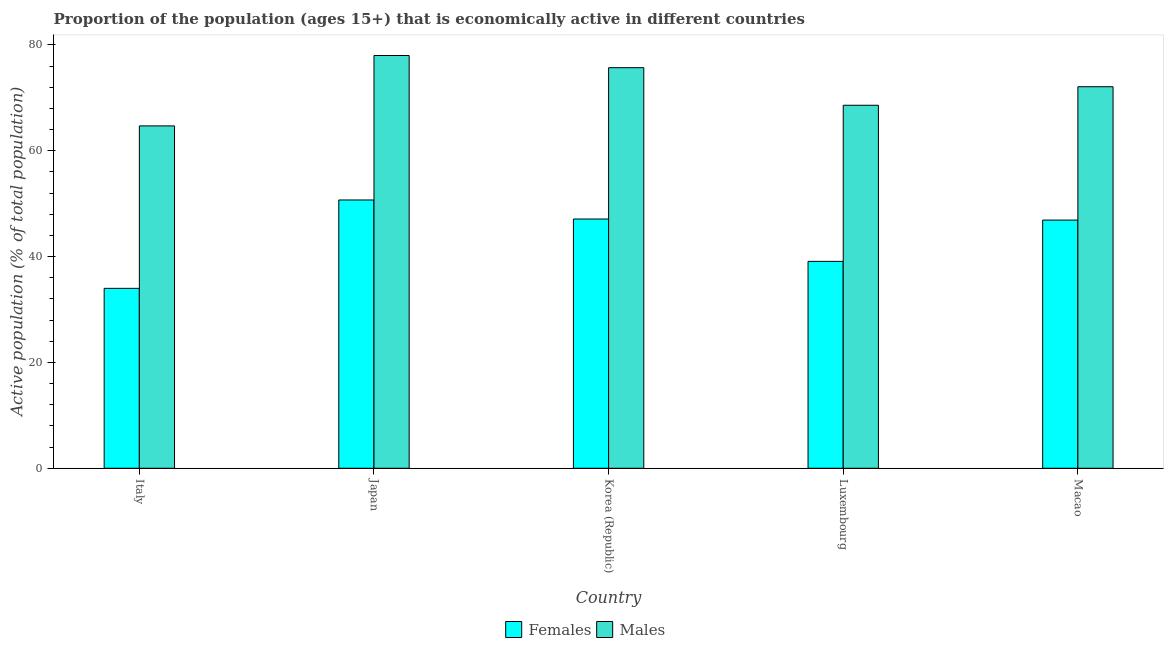How many groups of bars are there?
Offer a very short reply. 5. Are the number of bars per tick equal to the number of legend labels?
Provide a short and direct response. Yes. Are the number of bars on each tick of the X-axis equal?
Give a very brief answer. Yes. How many bars are there on the 1st tick from the left?
Keep it short and to the point. 2. How many bars are there on the 3rd tick from the right?
Provide a succinct answer. 2. What is the percentage of economically active male population in Korea (Republic)?
Provide a short and direct response. 75.7. Across all countries, what is the maximum percentage of economically active female population?
Your response must be concise. 50.7. Across all countries, what is the minimum percentage of economically active female population?
Offer a terse response. 34. In which country was the percentage of economically active female population minimum?
Provide a short and direct response. Italy. What is the total percentage of economically active female population in the graph?
Provide a succinct answer. 217.8. What is the difference between the percentage of economically active male population in Italy and that in Macao?
Provide a succinct answer. -7.4. What is the difference between the percentage of economically active female population in Japan and the percentage of economically active male population in Korea (Republic)?
Your response must be concise. -25. What is the average percentage of economically active male population per country?
Give a very brief answer. 71.82. What is the difference between the percentage of economically active male population and percentage of economically active female population in Macao?
Your answer should be compact. 25.2. What is the ratio of the percentage of economically active male population in Korea (Republic) to that in Macao?
Give a very brief answer. 1.05. Is the percentage of economically active male population in Japan less than that in Macao?
Keep it short and to the point. No. Is the difference between the percentage of economically active male population in Japan and Macao greater than the difference between the percentage of economically active female population in Japan and Macao?
Your answer should be very brief. Yes. What is the difference between the highest and the second highest percentage of economically active male population?
Your response must be concise. 2.3. What is the difference between the highest and the lowest percentage of economically active female population?
Your answer should be very brief. 16.7. What does the 1st bar from the left in Macao represents?
Make the answer very short. Females. What does the 2nd bar from the right in Italy represents?
Make the answer very short. Females. Are all the bars in the graph horizontal?
Keep it short and to the point. No. How many countries are there in the graph?
Offer a very short reply. 5. Are the values on the major ticks of Y-axis written in scientific E-notation?
Provide a short and direct response. No. Does the graph contain any zero values?
Provide a succinct answer. No. Does the graph contain grids?
Your response must be concise. No. Where does the legend appear in the graph?
Your response must be concise. Bottom center. How many legend labels are there?
Your answer should be compact. 2. How are the legend labels stacked?
Offer a very short reply. Horizontal. What is the title of the graph?
Give a very brief answer. Proportion of the population (ages 15+) that is economically active in different countries. What is the label or title of the X-axis?
Make the answer very short. Country. What is the label or title of the Y-axis?
Offer a very short reply. Active population (% of total population). What is the Active population (% of total population) of Females in Italy?
Provide a succinct answer. 34. What is the Active population (% of total population) of Males in Italy?
Offer a very short reply. 64.7. What is the Active population (% of total population) in Females in Japan?
Your answer should be very brief. 50.7. What is the Active population (% of total population) of Females in Korea (Republic)?
Give a very brief answer. 47.1. What is the Active population (% of total population) of Males in Korea (Republic)?
Your response must be concise. 75.7. What is the Active population (% of total population) of Females in Luxembourg?
Your response must be concise. 39.1. What is the Active population (% of total population) in Males in Luxembourg?
Ensure brevity in your answer.  68.6. What is the Active population (% of total population) in Females in Macao?
Your answer should be compact. 46.9. What is the Active population (% of total population) in Males in Macao?
Make the answer very short. 72.1. Across all countries, what is the maximum Active population (% of total population) of Females?
Your response must be concise. 50.7. Across all countries, what is the minimum Active population (% of total population) in Males?
Give a very brief answer. 64.7. What is the total Active population (% of total population) in Females in the graph?
Make the answer very short. 217.8. What is the total Active population (% of total population) in Males in the graph?
Your answer should be very brief. 359.1. What is the difference between the Active population (% of total population) of Females in Italy and that in Japan?
Your answer should be very brief. -16.7. What is the difference between the Active population (% of total population) of Females in Japan and that in Korea (Republic)?
Provide a short and direct response. 3.6. What is the difference between the Active population (% of total population) of Males in Japan and that in Macao?
Provide a short and direct response. 5.9. What is the difference between the Active population (% of total population) of Males in Korea (Republic) and that in Macao?
Provide a short and direct response. 3.6. What is the difference between the Active population (% of total population) of Females in Luxembourg and that in Macao?
Your answer should be compact. -7.8. What is the difference between the Active population (% of total population) of Males in Luxembourg and that in Macao?
Give a very brief answer. -3.5. What is the difference between the Active population (% of total population) of Females in Italy and the Active population (% of total population) of Males in Japan?
Make the answer very short. -44. What is the difference between the Active population (% of total population) in Females in Italy and the Active population (% of total population) in Males in Korea (Republic)?
Give a very brief answer. -41.7. What is the difference between the Active population (% of total population) of Females in Italy and the Active population (% of total population) of Males in Luxembourg?
Your answer should be compact. -34.6. What is the difference between the Active population (% of total population) in Females in Italy and the Active population (% of total population) in Males in Macao?
Offer a terse response. -38.1. What is the difference between the Active population (% of total population) in Females in Japan and the Active population (% of total population) in Males in Korea (Republic)?
Give a very brief answer. -25. What is the difference between the Active population (% of total population) of Females in Japan and the Active population (% of total population) of Males in Luxembourg?
Keep it short and to the point. -17.9. What is the difference between the Active population (% of total population) of Females in Japan and the Active population (% of total population) of Males in Macao?
Provide a succinct answer. -21.4. What is the difference between the Active population (% of total population) of Females in Korea (Republic) and the Active population (% of total population) of Males in Luxembourg?
Ensure brevity in your answer.  -21.5. What is the difference between the Active population (% of total population) in Females in Luxembourg and the Active population (% of total population) in Males in Macao?
Provide a succinct answer. -33. What is the average Active population (% of total population) in Females per country?
Offer a terse response. 43.56. What is the average Active population (% of total population) in Males per country?
Provide a succinct answer. 71.82. What is the difference between the Active population (% of total population) in Females and Active population (% of total population) in Males in Italy?
Provide a succinct answer. -30.7. What is the difference between the Active population (% of total population) in Females and Active population (% of total population) in Males in Japan?
Your answer should be compact. -27.3. What is the difference between the Active population (% of total population) in Females and Active population (% of total population) in Males in Korea (Republic)?
Your answer should be compact. -28.6. What is the difference between the Active population (% of total population) in Females and Active population (% of total population) in Males in Luxembourg?
Ensure brevity in your answer.  -29.5. What is the difference between the Active population (% of total population) of Females and Active population (% of total population) of Males in Macao?
Make the answer very short. -25.2. What is the ratio of the Active population (% of total population) of Females in Italy to that in Japan?
Your answer should be very brief. 0.67. What is the ratio of the Active population (% of total population) in Males in Italy to that in Japan?
Your response must be concise. 0.83. What is the ratio of the Active population (% of total population) in Females in Italy to that in Korea (Republic)?
Your answer should be compact. 0.72. What is the ratio of the Active population (% of total population) in Males in Italy to that in Korea (Republic)?
Keep it short and to the point. 0.85. What is the ratio of the Active population (% of total population) of Females in Italy to that in Luxembourg?
Keep it short and to the point. 0.87. What is the ratio of the Active population (% of total population) in Males in Italy to that in Luxembourg?
Your response must be concise. 0.94. What is the ratio of the Active population (% of total population) in Females in Italy to that in Macao?
Provide a short and direct response. 0.72. What is the ratio of the Active population (% of total population) in Males in Italy to that in Macao?
Offer a terse response. 0.9. What is the ratio of the Active population (% of total population) in Females in Japan to that in Korea (Republic)?
Your answer should be compact. 1.08. What is the ratio of the Active population (% of total population) in Males in Japan to that in Korea (Republic)?
Offer a very short reply. 1.03. What is the ratio of the Active population (% of total population) of Females in Japan to that in Luxembourg?
Ensure brevity in your answer.  1.3. What is the ratio of the Active population (% of total population) in Males in Japan to that in Luxembourg?
Keep it short and to the point. 1.14. What is the ratio of the Active population (% of total population) in Females in Japan to that in Macao?
Give a very brief answer. 1.08. What is the ratio of the Active population (% of total population) in Males in Japan to that in Macao?
Provide a succinct answer. 1.08. What is the ratio of the Active population (% of total population) of Females in Korea (Republic) to that in Luxembourg?
Your answer should be compact. 1.2. What is the ratio of the Active population (% of total population) in Males in Korea (Republic) to that in Luxembourg?
Offer a terse response. 1.1. What is the ratio of the Active population (% of total population) in Females in Korea (Republic) to that in Macao?
Keep it short and to the point. 1. What is the ratio of the Active population (% of total population) in Males in Korea (Republic) to that in Macao?
Ensure brevity in your answer.  1.05. What is the ratio of the Active population (% of total population) of Females in Luxembourg to that in Macao?
Keep it short and to the point. 0.83. What is the ratio of the Active population (% of total population) in Males in Luxembourg to that in Macao?
Give a very brief answer. 0.95. What is the difference between the highest and the second highest Active population (% of total population) in Females?
Provide a succinct answer. 3.6. What is the difference between the highest and the second highest Active population (% of total population) of Males?
Your answer should be very brief. 2.3. 